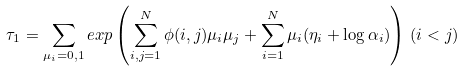Convert formula to latex. <formula><loc_0><loc_0><loc_500><loc_500>\tau _ { 1 } = \sum _ { \mu _ { i } = 0 , 1 } e x p \left ( \sum _ { i , j = 1 } ^ { N } \phi ( i , j ) \mu _ { i } \mu _ { j } + \sum _ { i = 1 } ^ { N } \mu _ { i } ( \eta _ { i } + \log \alpha _ { i } ) \right ) \, ( i < j )</formula> 